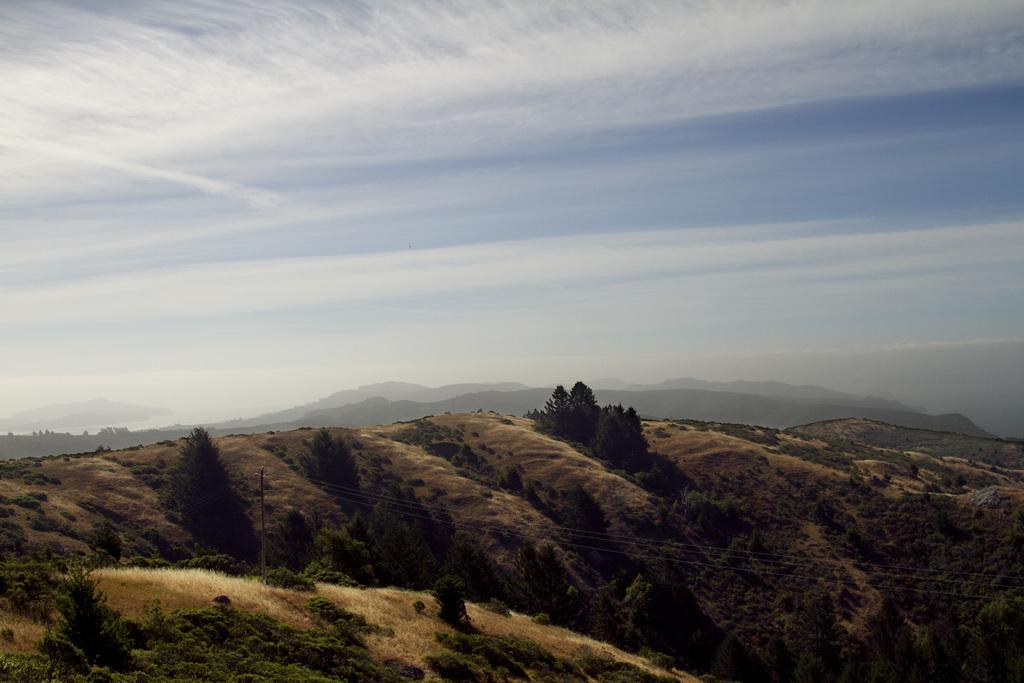What is attached to the pole in the image? There are electric lines attached to a pole in the image. What can be seen on the mountains in the image? There are plants, a tree, and grass on the mountains in the image. What is visible in the sky in the background of the image? There are clouds in the blue sky in the background of the image. Can you tell me who won the argument in the image? There is no argument present in the image; it features electric lines, plants, a tree, grass, and clouds in the sky. What wish does the tree on the mountains grant in the image? There is no mention of wishes or magical abilities in the image; it simply shows a tree on the mountains. 